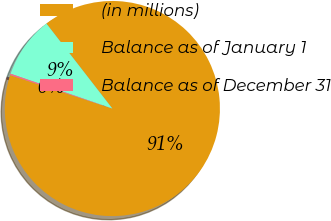Convert chart. <chart><loc_0><loc_0><loc_500><loc_500><pie_chart><fcel>(in millions)<fcel>Balance as of January 1<fcel>Balance as of December 31<nl><fcel>90.52%<fcel>9.25%<fcel>0.22%<nl></chart> 